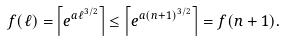<formula> <loc_0><loc_0><loc_500><loc_500>f ( \ell ) = \left \lceil e ^ { a \ell ^ { 3 / 2 } } \right \rceil \leq \left \lceil e ^ { a ( n + 1 ) ^ { 3 / 2 } } \right \rceil = f ( n + 1 ) .</formula> 